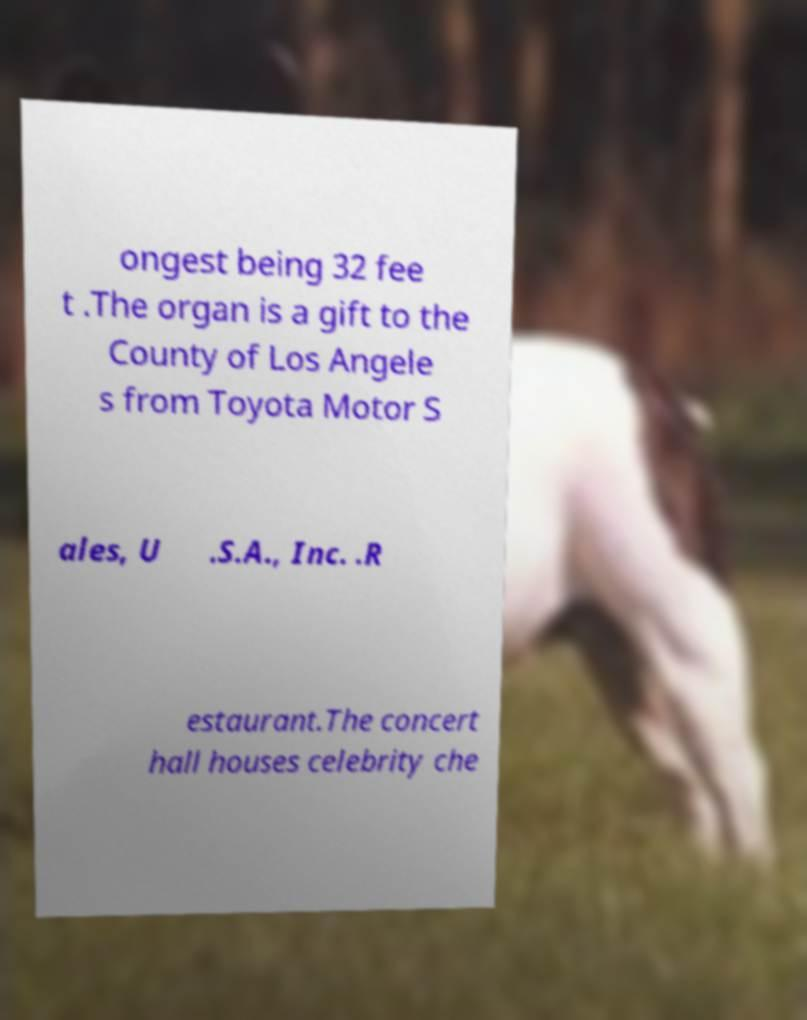I need the written content from this picture converted into text. Can you do that? ongest being 32 fee t .The organ is a gift to the County of Los Angele s from Toyota Motor S ales, U .S.A., Inc. .R estaurant.The concert hall houses celebrity che 